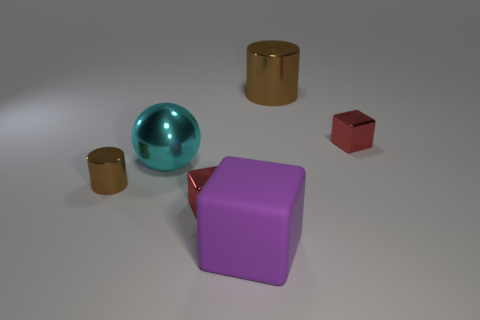Are there any things of the same color as the small cylinder?
Ensure brevity in your answer.  Yes. What is the size of the other metallic cylinder that is the same color as the big metallic cylinder?
Keep it short and to the point. Small. The brown cylinder that is made of the same material as the large brown thing is what size?
Give a very brief answer. Small. The tiny thing that is the same color as the large metallic cylinder is what shape?
Your response must be concise. Cylinder. How many small yellow spheres are there?
Provide a short and direct response. 0. The brown object that is the same material as the large brown cylinder is what shape?
Your answer should be compact. Cylinder. Is there anything else of the same color as the tiny metal cylinder?
Keep it short and to the point. Yes. There is a big metal sphere; is it the same color as the small shiny thing that is on the left side of the big cyan sphere?
Provide a succinct answer. No. Are there fewer big brown objects that are in front of the purple matte thing than big brown rubber cylinders?
Your answer should be compact. No. There is a tiny red block that is behind the big cyan metal sphere; what material is it?
Your answer should be compact. Metal. 